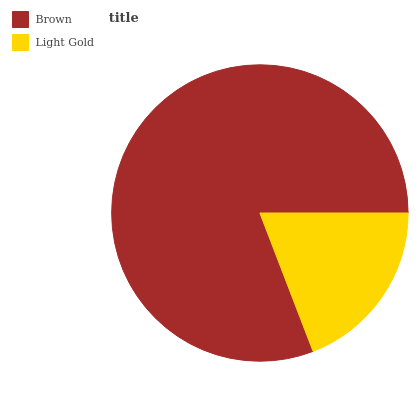Is Light Gold the minimum?
Answer yes or no. Yes. Is Brown the maximum?
Answer yes or no. Yes. Is Light Gold the maximum?
Answer yes or no. No. Is Brown greater than Light Gold?
Answer yes or no. Yes. Is Light Gold less than Brown?
Answer yes or no. Yes. Is Light Gold greater than Brown?
Answer yes or no. No. Is Brown less than Light Gold?
Answer yes or no. No. Is Brown the high median?
Answer yes or no. Yes. Is Light Gold the low median?
Answer yes or no. Yes. Is Light Gold the high median?
Answer yes or no. No. Is Brown the low median?
Answer yes or no. No. 